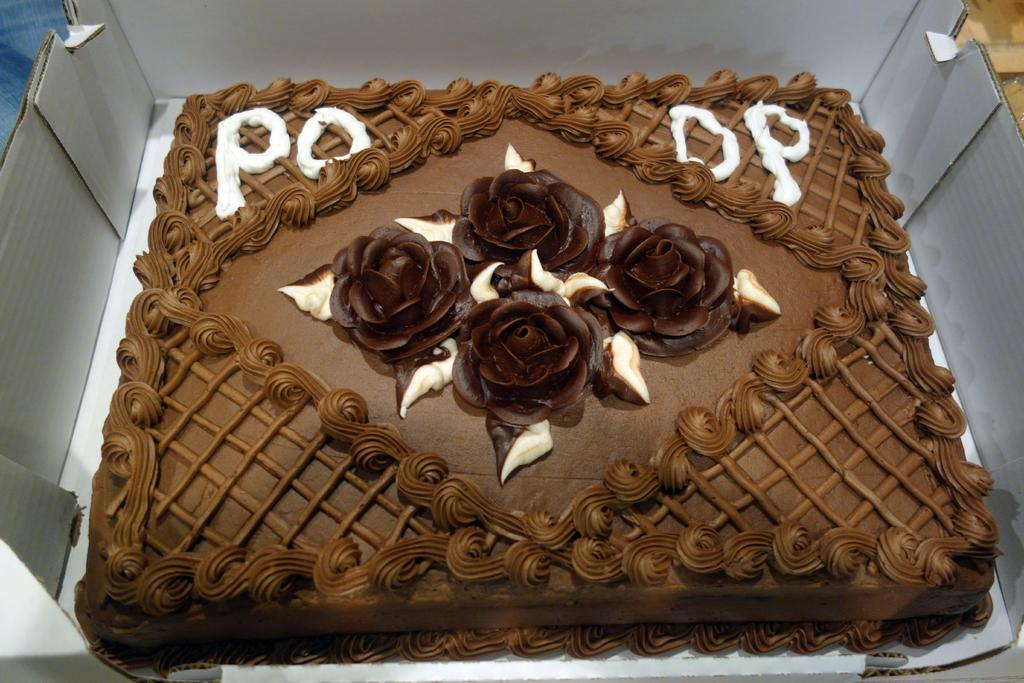What is the main subject of the image? There is a cake in the image. Is there any writing or text on the cake? Yes, there is text on the cake. How is the cake being stored or transported? The cake is placed in a box. What type of jam is being used to decorate the toad on the cake? There is no toad or jam present on the cake in the image. 